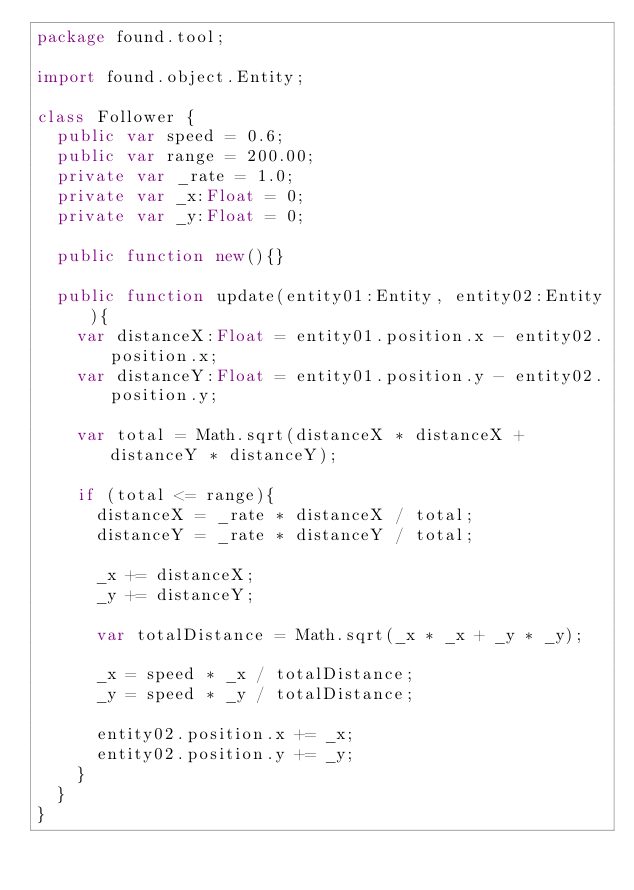<code> <loc_0><loc_0><loc_500><loc_500><_Haxe_>package found.tool;

import found.object.Entity;

class Follower {
	public var speed = 0.6;
	public var range = 200.00;
	private var _rate = 1.0;
	private var _x:Float = 0;
	private var _y:Float = 0;

	public function new(){}

	public function update(entity01:Entity, entity02:Entity){
		var distanceX:Float = entity01.position.x - entity02.position.x;
		var distanceY:Float = entity01.position.y - entity02.position.y;

		var total = Math.sqrt(distanceX * distanceX + distanceY * distanceY);

		if (total <= range){
			distanceX = _rate * distanceX / total;
			distanceY = _rate * distanceY / total;

			_x += distanceX;
			_y += distanceY;

			var totalDistance = Math.sqrt(_x * _x + _y * _y);

			_x = speed * _x / totalDistance;
			_y = speed * _y / totalDistance;

			entity02.position.x += _x;
			entity02.position.y += _y;
		}
	}
}</code> 